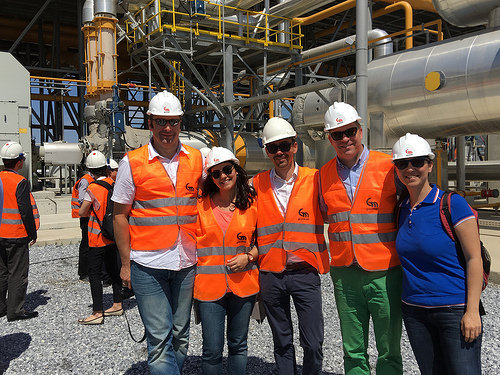<image>
Is there a man next to the man? No. The man is not positioned next to the man. They are located in different areas of the scene. Is the girl in front of the girl? No. The girl is not in front of the girl. The spatial positioning shows a different relationship between these objects. 